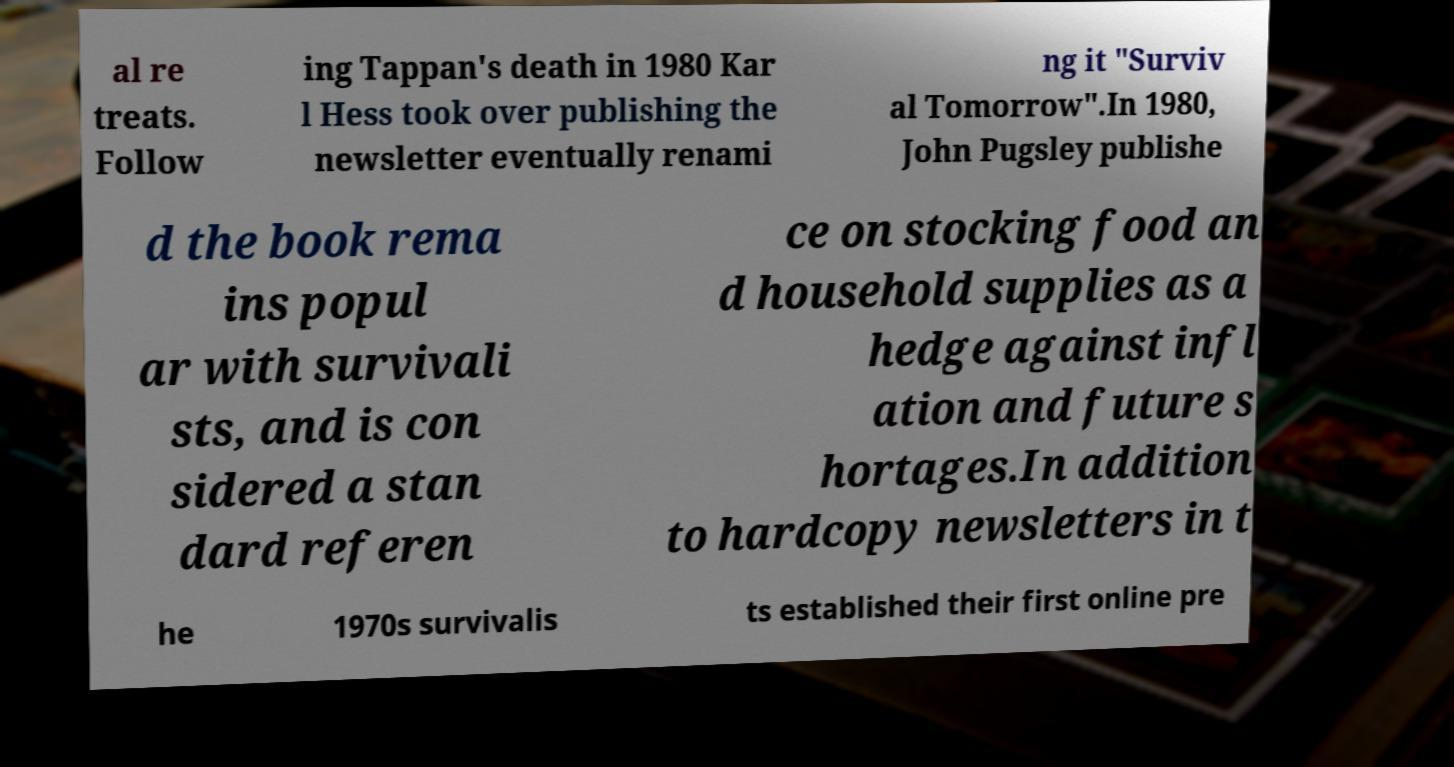Could you assist in decoding the text presented in this image and type it out clearly? al re treats. Follow ing Tappan's death in 1980 Kar l Hess took over publishing the newsletter eventually renami ng it "Surviv al Tomorrow".In 1980, John Pugsley publishe d the book rema ins popul ar with survivali sts, and is con sidered a stan dard referen ce on stocking food an d household supplies as a hedge against infl ation and future s hortages.In addition to hardcopy newsletters in t he 1970s survivalis ts established their first online pre 